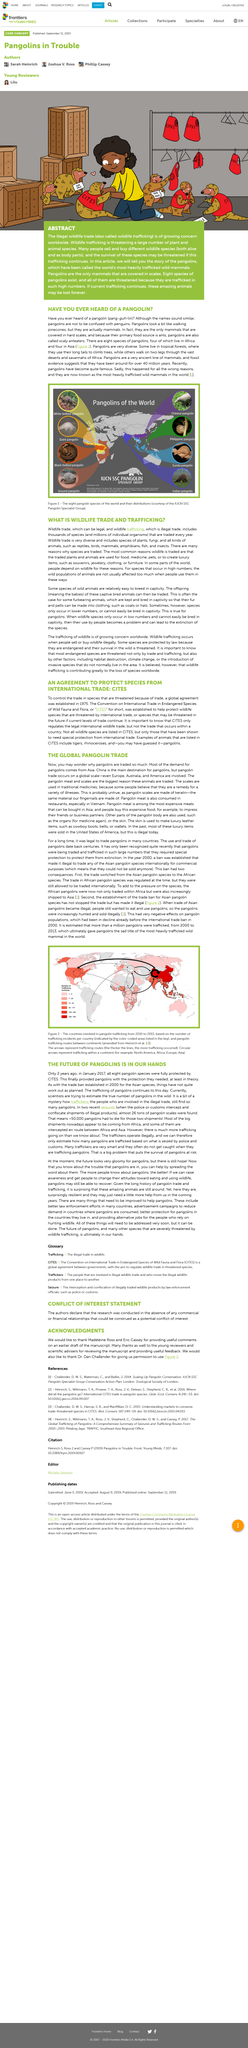Draw attention to some important aspects in this diagram. The world's most heavily trafficked wild mammals, pangolins, have been referred to as such due to the high volume of illegal hunting and trade they are subjected to. Yes, wildlife trade can be legal. Wildlife trade and trafficking are not the only reasons that endangered species are threatened with extinction. Eight species of pangolins exist. Wildlife trafficking is the buying and selling of different wildlife species, both alive and as body parts, which is a serious global issue that threatens the survival of many species and violates the laws of many countries. 